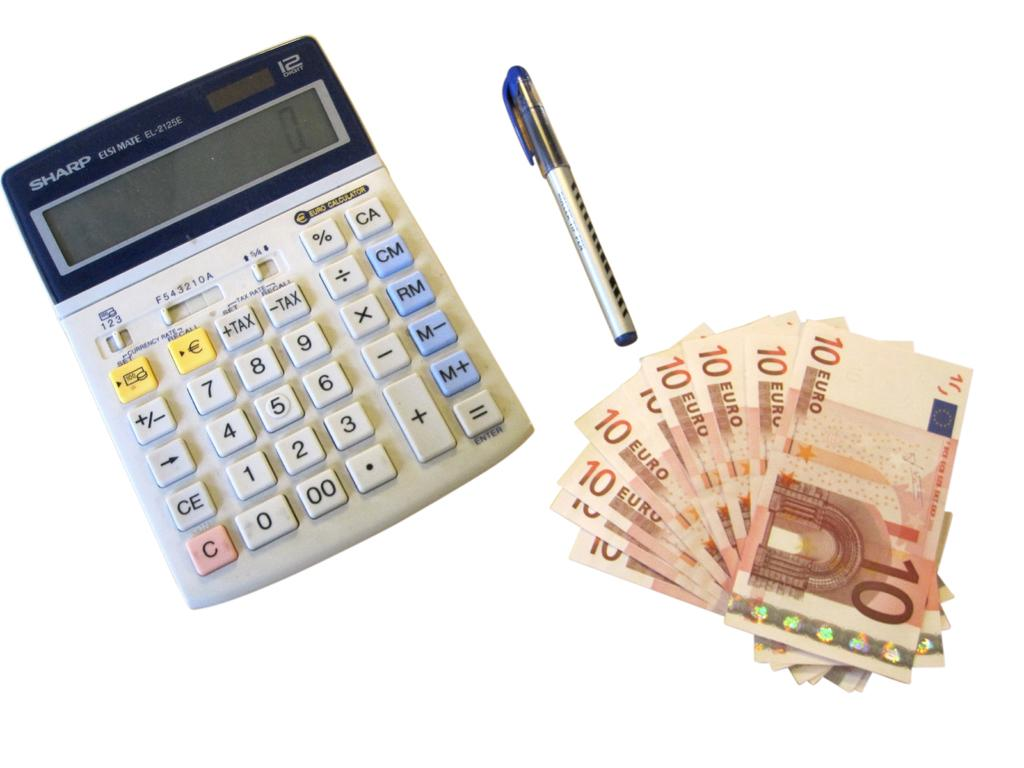<image>
Give a short and clear explanation of the subsequent image. A calculator set to 0 is next to 6 10 euro bills 